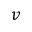<formula> <loc_0><loc_0><loc_500><loc_500>v</formula> 